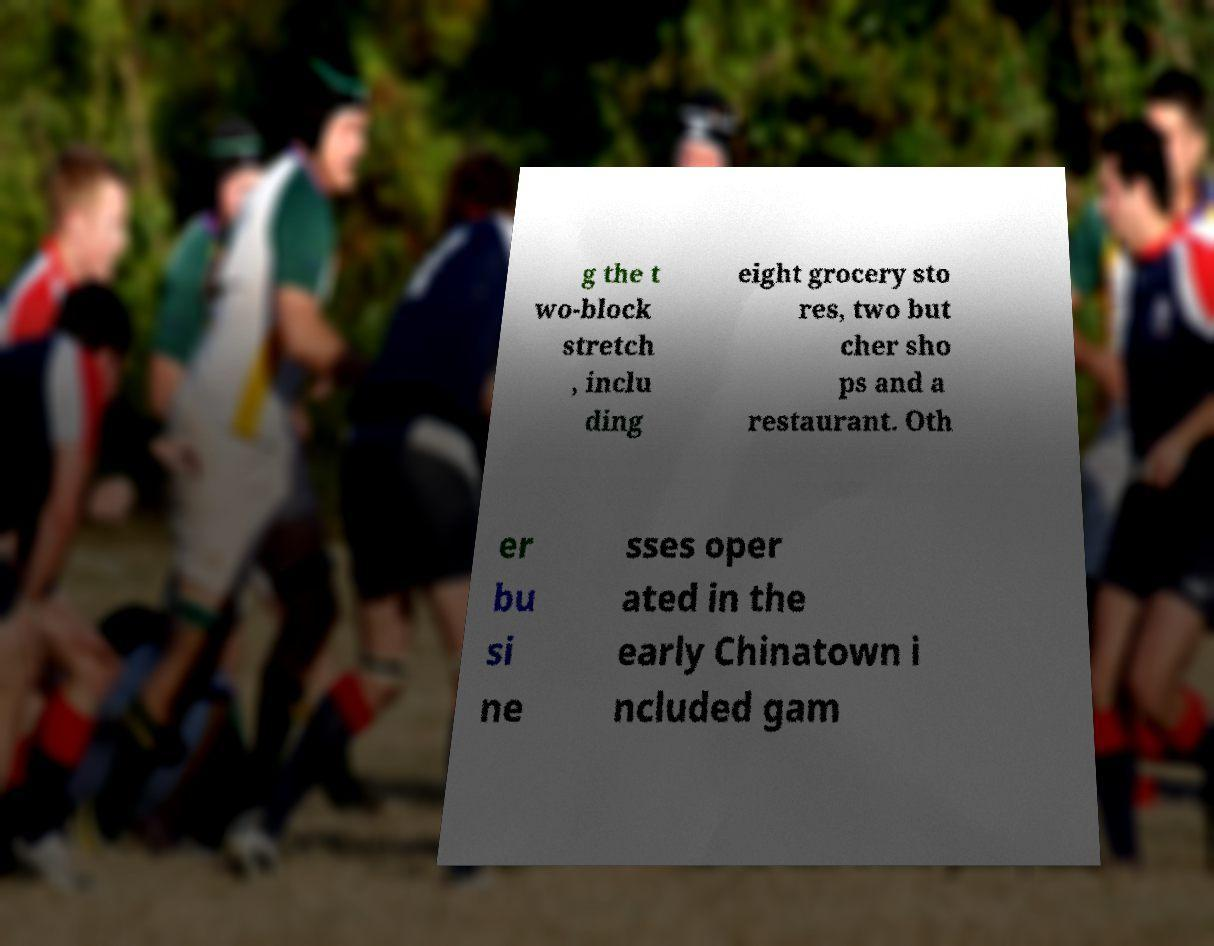I need the written content from this picture converted into text. Can you do that? g the t wo-block stretch , inclu ding eight grocery sto res, two but cher sho ps and a restaurant. Oth er bu si ne sses oper ated in the early Chinatown i ncluded gam 